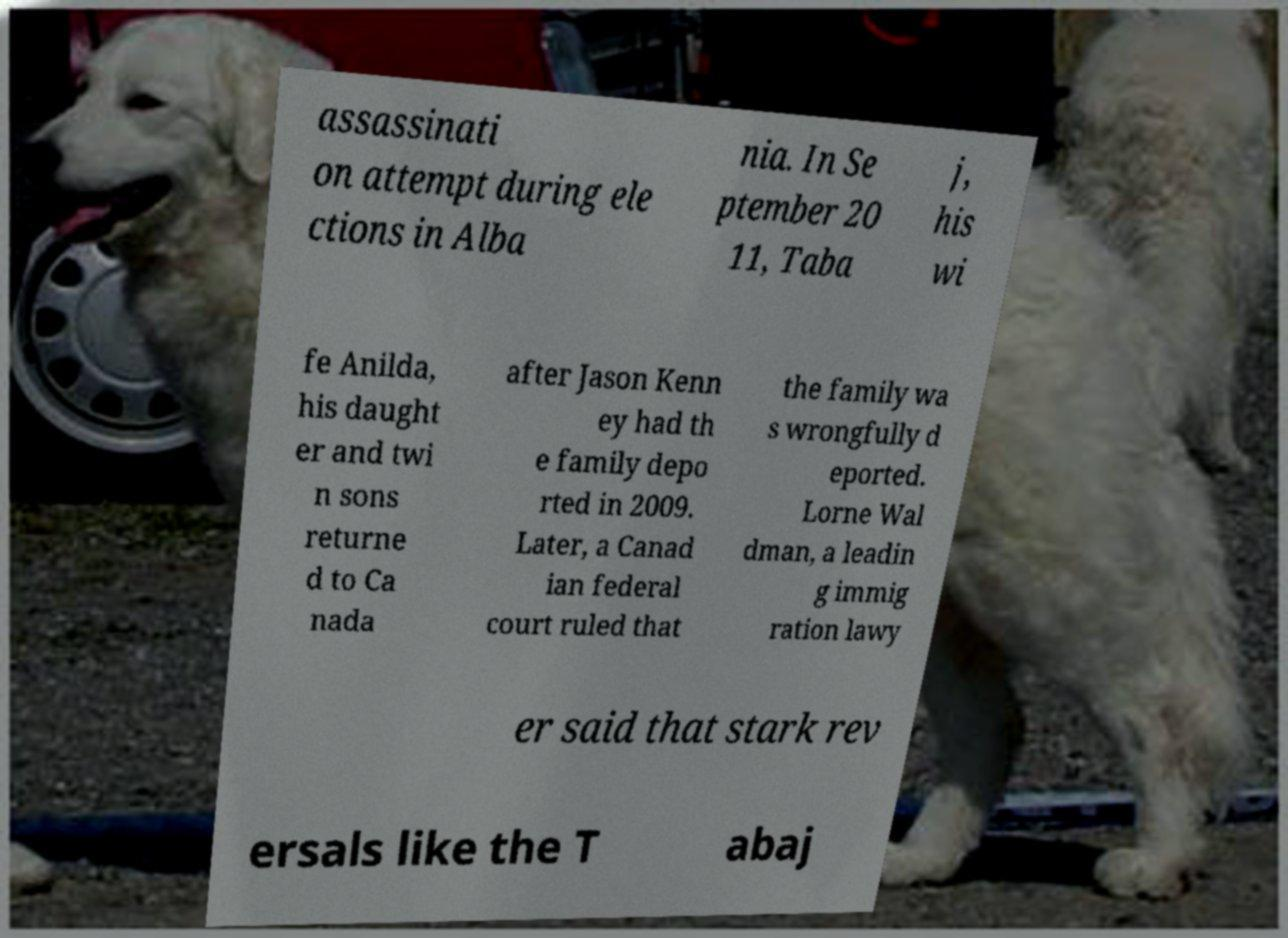Can you accurately transcribe the text from the provided image for me? assassinati on attempt during ele ctions in Alba nia. In Se ptember 20 11, Taba j, his wi fe Anilda, his daught er and twi n sons returne d to Ca nada after Jason Kenn ey had th e family depo rted in 2009. Later, a Canad ian federal court ruled that the family wa s wrongfully d eported. Lorne Wal dman, a leadin g immig ration lawy er said that stark rev ersals like the T abaj 